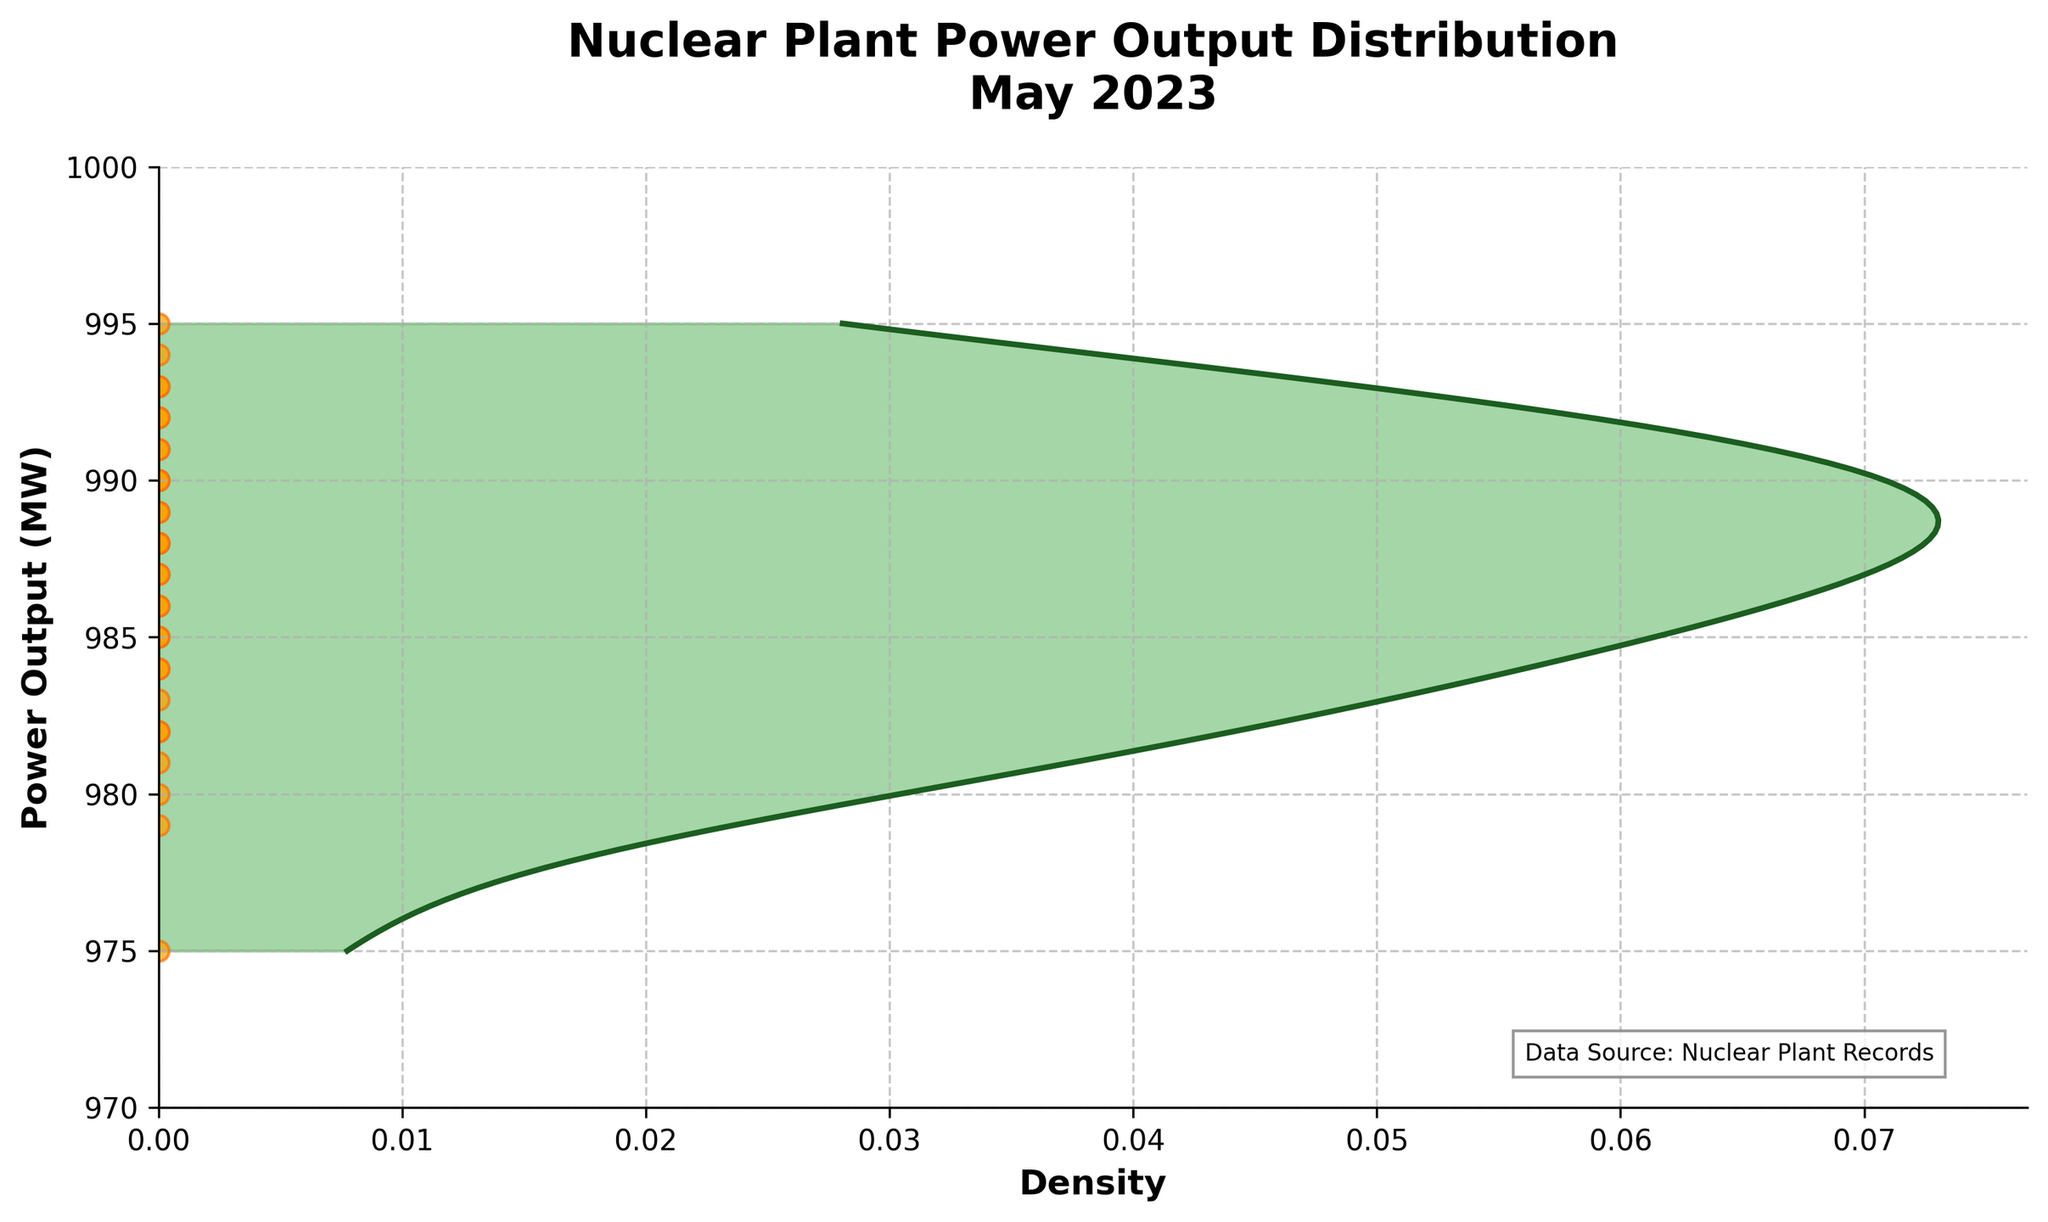What is the title of the plot? The title is located at the top of the plot and usually provides a brief description of the visualization.
Answer: Nuclear Plant Power Output Distribution May 2023 What values are shown on the y-axis? The y-axis shows the range of power output values in megawatts (MW).
Answer: Power Output (MW) What is the range of power output values displayed in this plot? By looking at the vertical axis (y-axis), we can see the power output values range from 970 MW to 1000 MW.
Answer: 970 MW to 1000 MW How many data points are there in the scatter plot? The scatter plot represents each day's power output as an individual point, and by counting all these points, we can determine there are 31 data points.
Answer: 31 What does the color green represent in the plot? In the plot, the green color represents the density of the power output distribution, with areas of higher density shown more prominently.
Answer: Density Which power output value appears with the highest density? The peak of the density curve, where it reaches its maximum within the filled green area, indicates the power output value with the highest density.
Answer: Approximately 990 MW How does the density of power outputs below 980 MW compare to those above 990 MW? By observing the density curves, it is clear that densities below 980 MW are lower and less frequent, whereas densities above 990 MW appear more frequently but show some decreasing patterns.
Answer: Densities below 980 MW are lower What color are the scatter plot points, and what does it signify? The scatter plot points are orange, which signify the actual power output data points for each day of the month.
Answer: Orange Is there a day where the power output is precisely 995 MW? By looking at the scatter plot points lined up with the y-axis values, we can see if any points are directly aligned with 995 MW.
Answer: Yes Which end of the power output density shows more variability? By examining the width and spread of the density curve on either end, we can determine which end has a more considerable spread, indicating higher variability.
Answer: Lower end (below 980 MW) 